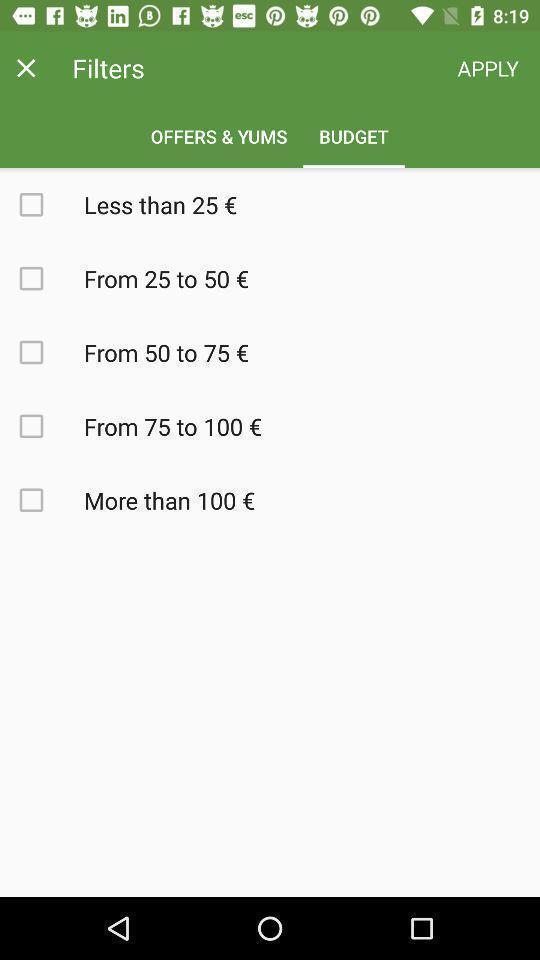Tell me what you see in this picture. Page to set budget filter in the food delivery app. 